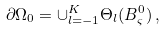<formula> <loc_0><loc_0><loc_500><loc_500>\partial \Omega _ { 0 } = \cup _ { l = - 1 } ^ { K } \Theta _ { l } ( B _ { \varsigma } ^ { 0 } ) \, ,</formula> 